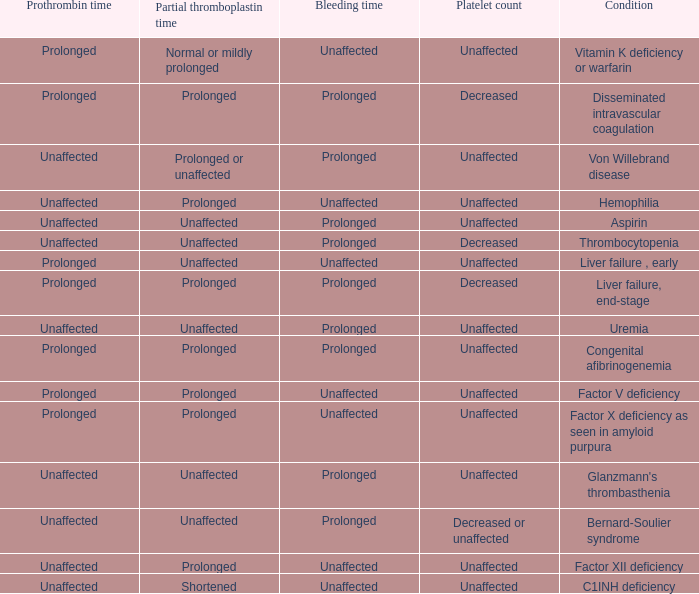Which partial thromboplastin time has a condition of liver failure , early? Unaffected. 